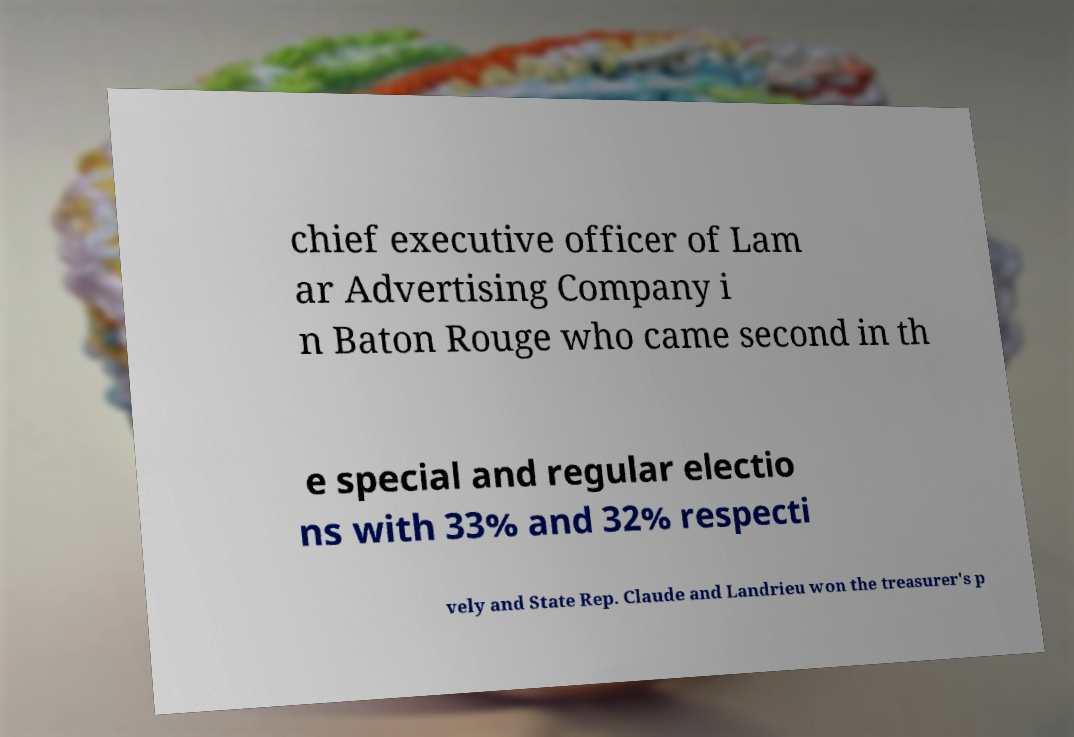What messages or text are displayed in this image? I need them in a readable, typed format. chief executive officer of Lam ar Advertising Company i n Baton Rouge who came second in th e special and regular electio ns with 33% and 32% respecti vely and State Rep. Claude and Landrieu won the treasurer's p 